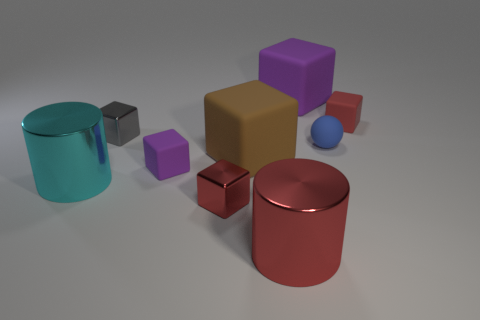Is the number of large cyan metal objects to the left of the tiny blue rubber object less than the number of small blocks that are behind the brown matte cube?
Provide a succinct answer. Yes. Is there anything else that has the same shape as the small blue matte object?
Make the answer very short. No. What is the purple cube behind the big brown object made of?
Offer a very short reply. Rubber. There is a brown object; are there any red objects right of it?
Your response must be concise. Yes. There is a large red object; what shape is it?
Your answer should be compact. Cylinder. What number of things are tiny red cubes behind the tiny matte ball or metallic things?
Provide a short and direct response. 5. There is another large thing that is the same shape as the big purple rubber object; what color is it?
Provide a succinct answer. Brown. Are the small blue sphere and the purple object in front of the tiny rubber sphere made of the same material?
Provide a short and direct response. Yes. The tiny rubber sphere is what color?
Keep it short and to the point. Blue. What color is the small rubber thing that is behind the blue matte thing on the left side of the small cube that is to the right of the tiny red metal thing?
Give a very brief answer. Red. 